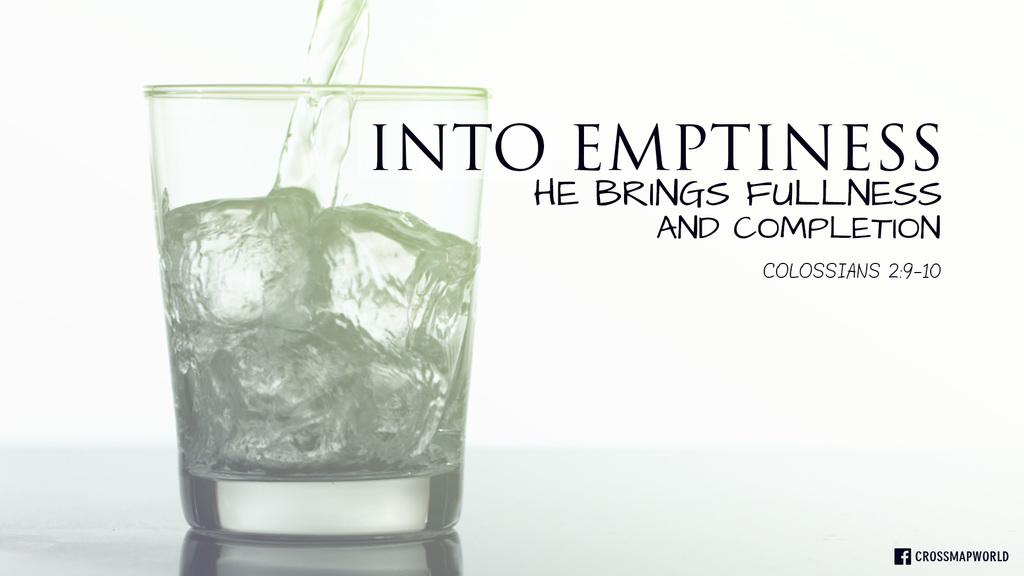<image>
Render a clear and concise summary of the photo. a glass with liquid next to a quote saying into emptiness he brings fullness and completion 